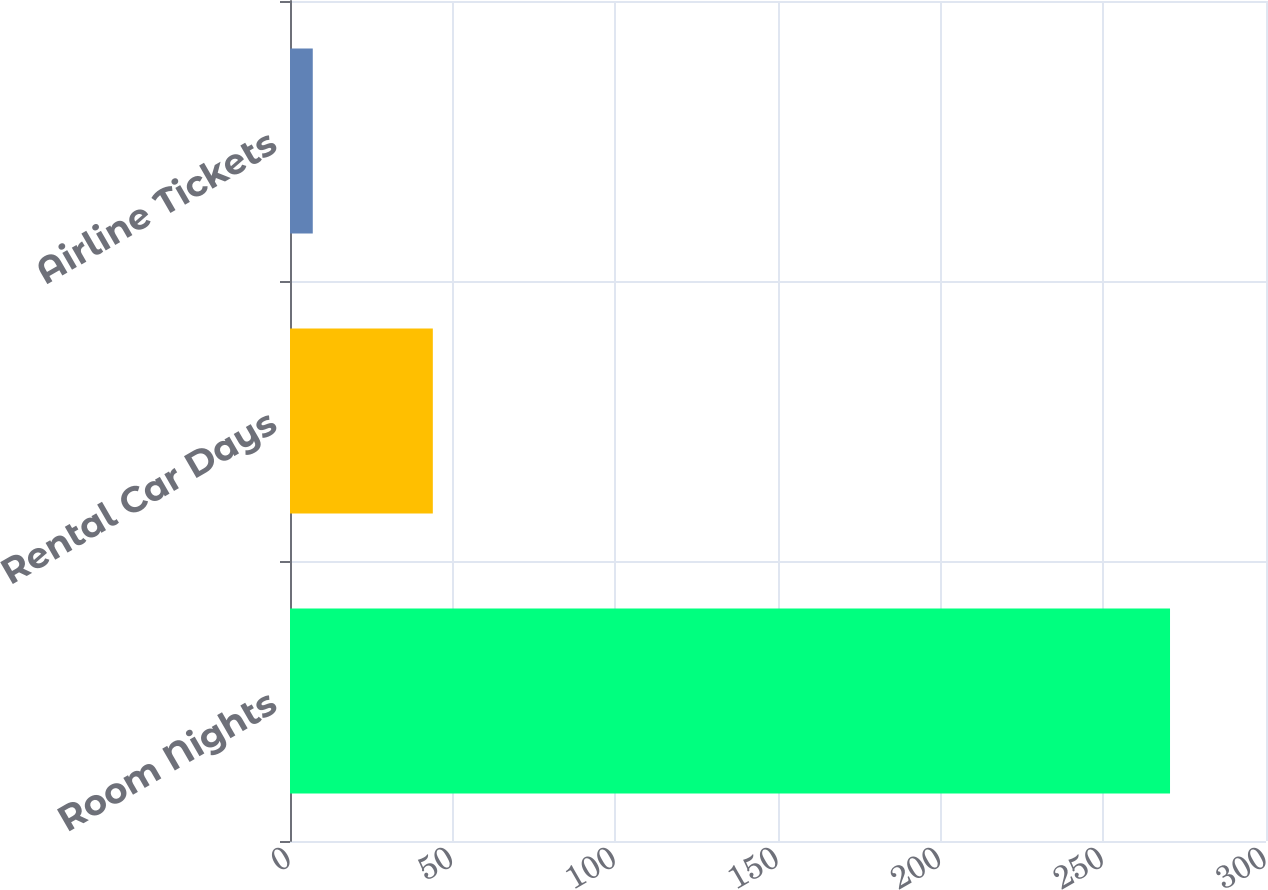Convert chart to OTSL. <chart><loc_0><loc_0><loc_500><loc_500><bar_chart><fcel>Room Nights<fcel>Rental Car Days<fcel>Airline Tickets<nl><fcel>270.5<fcel>43.9<fcel>7<nl></chart> 